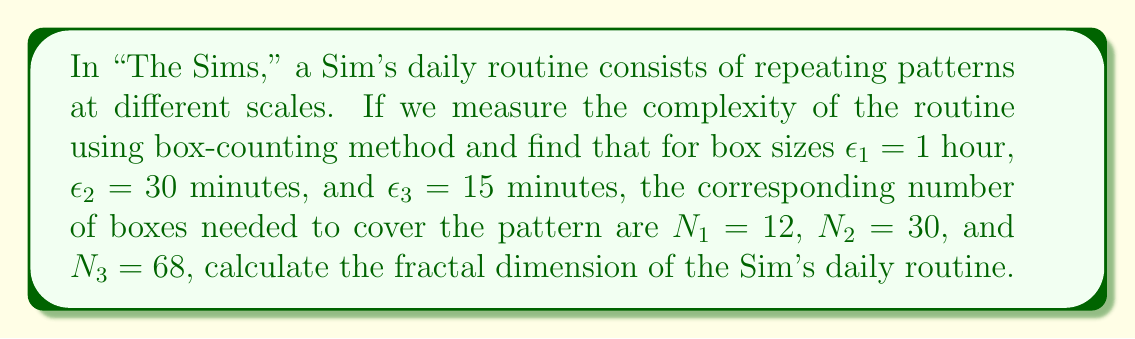Solve this math problem. To calculate the fractal dimension using the box-counting method, we'll use the formula:

$$D = \lim_{\epsilon \to 0} \frac{\log N(\epsilon)}{\log(1/\epsilon)}$$

Where $D$ is the fractal dimension, $N(\epsilon)$ is the number of boxes of size $\epsilon$ needed to cover the pattern.

Step 1: Prepare the data
Let's organize our data:
$\epsilon_1 = 1$ hour, $N_1 = 12$
$\epsilon_2 = 0.5$ hour, $N_2 = 30$
$\epsilon_3 = 0.25$ hour, $N_3 = 68$

Step 2: Calculate $\log N(\epsilon)$ and $\log(1/\epsilon)$ for each scale
For $\epsilon_1$: $\log N(\epsilon_1) = \log 12$, $\log(1/\epsilon_1) = \log 1 = 0$
For $\epsilon_2$: $\log N(\epsilon_2) = \log 30$, $\log(1/\epsilon_2) = \log 2$
For $\epsilon_3$: $\log N(\epsilon_3) = \log 68$, $\log(1/\epsilon_3) = \log 4$

Step 3: Plot $\log N(\epsilon)$ vs $\log(1/\epsilon)$
We can imagine a plot with these points:
(0, $\log 12$), ($\log 2$, $\log 30$), ($\log 4$, $\log 68$)

Step 4: Find the slope of the best-fit line
The slope of this line is our estimate of the fractal dimension. We can use the two extreme points to estimate this slope:

$$D \approx \frac{\log 68 - \log 12}{\log 4 - \log 1} = \frac{\log(68/12)}{\log 4}$$

Step 5: Calculate the fractal dimension
$$D \approx \frac{\log(68/12)}{\log 4} \approx 1.42$$

This fractal dimension suggests that the Sim's daily routine has a complexity between a one-dimensional line (D=1) and a two-dimensional plane (D=2), indicating a somewhat complex but not fully space-filling pattern.
Answer: $D \approx 1.42$ 